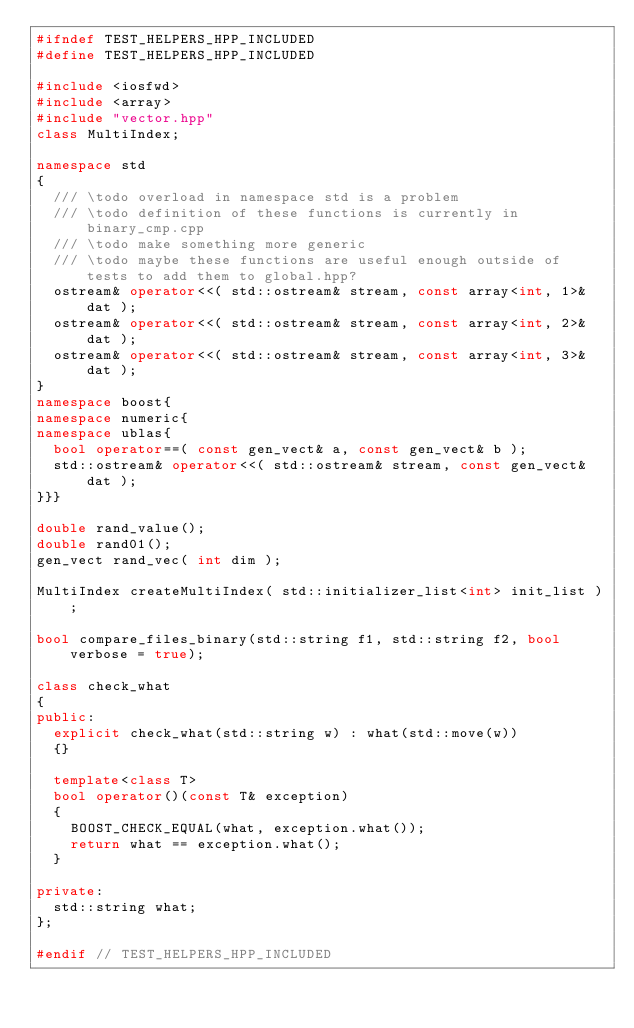<code> <loc_0><loc_0><loc_500><loc_500><_C++_>#ifndef TEST_HELPERS_HPP_INCLUDED
#define TEST_HELPERS_HPP_INCLUDED

#include <iosfwd>
#include <array>
#include "vector.hpp"
class MultiIndex;

namespace std
{
	/// \todo overload in namespace std is a problem
	/// \todo definition of these functions is currently in binary_cmp.cpp
	/// \todo make something more generic
	/// \todo maybe these functions are useful enough outside of tests to add them to global.hpp?
	ostream& operator<<( std::ostream& stream, const array<int, 1>& dat );
	ostream& operator<<( std::ostream& stream, const array<int, 2>& dat );
	ostream& operator<<( std::ostream& stream, const array<int, 3>& dat );
}
namespace boost{
namespace numeric{
namespace ublas{
	bool operator==( const gen_vect& a, const gen_vect& b );
	std::ostream& operator<<( std::ostream& stream, const gen_vect& dat );
}}}

double rand_value();
double rand01();
gen_vect rand_vec( int dim );

MultiIndex createMultiIndex( std::initializer_list<int> init_list );

bool compare_files_binary(std::string f1, std::string f2, bool verbose = true);

class check_what
{
public:
	explicit check_what(std::string w) : what(std::move(w))
	{}

	template<class T>
	bool operator()(const T& exception)
	{
		BOOST_CHECK_EQUAL(what, exception.what());
		return what == exception.what();
	}

private:
	std::string what;
};

#endif // TEST_HELPERS_HPP_INCLUDED
</code> 